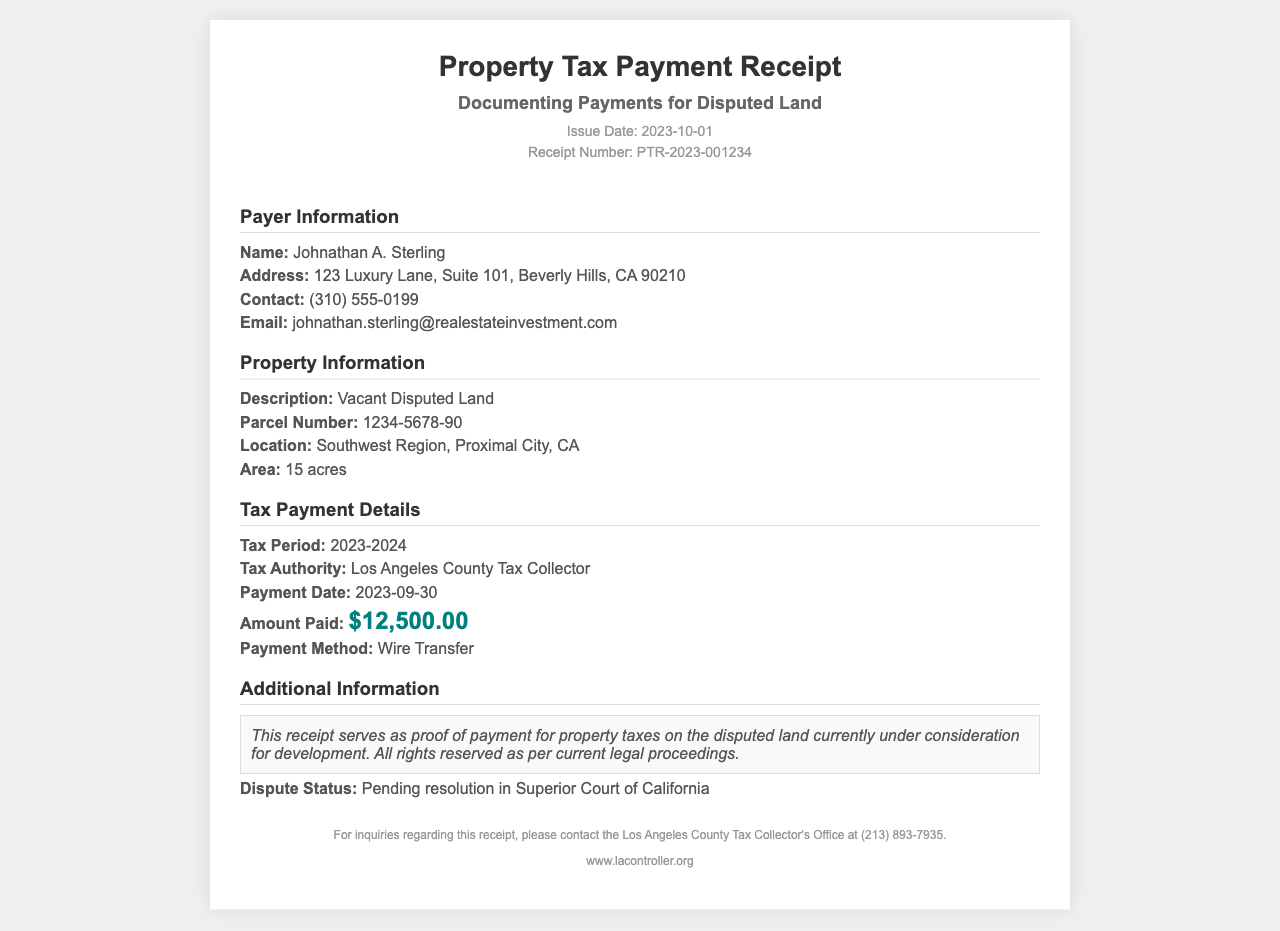What is the issue date of the receipt? The issue date is listed in the document under the header section.
Answer: 2023-10-01 Who is the payer? The payer's information is provided in the receipt.
Answer: Johnathan A. Sterling What is the amount paid for the property taxes? The amount paid is specifically mentioned in the tax payment details section.
Answer: $12,500.00 What is the property description? The property description can be found in the property information section of the document.
Answer: Vacant Disputed Land What is the parcel number? The parcel number is given in the property information section.
Answer: 1234-5678-90 What is the tax period for this payment? The tax period is clearly stated in the tax payment details.
Answer: 2023-2024 What payment method was used? The payment method is listed in the payment details section of the receipt.
Answer: Wire Transfer What is the dispute status? The dispute status is mentioned in the additional information section.
Answer: Pending resolution in Superior Court of California What is the total area of the property? The area is included in the property information section.
Answer: 15 acres 